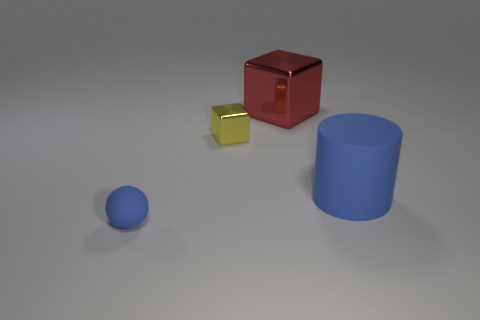How many small gray metallic blocks are there?
Offer a terse response. 0. What shape is the small blue matte object?
Keep it short and to the point. Sphere. What number of other rubber balls have the same size as the matte ball?
Provide a succinct answer. 0. Does the tiny blue rubber thing have the same shape as the large red shiny thing?
Your answer should be very brief. No. There is a metal object that is in front of the big red object that is right of the tiny yellow block; what is its color?
Ensure brevity in your answer.  Yellow. There is a object that is to the left of the big cube and behind the small ball; what size is it?
Your response must be concise. Small. Is there anything else that is the same color as the big matte cylinder?
Offer a very short reply. Yes. There is a blue thing that is the same material as the big blue cylinder; what shape is it?
Provide a succinct answer. Sphere. Is the shape of the large blue rubber object the same as the big object that is to the left of the large blue matte object?
Your response must be concise. No. What is the material of the blue object that is on the right side of the large block left of the large blue rubber cylinder?
Keep it short and to the point. Rubber. 